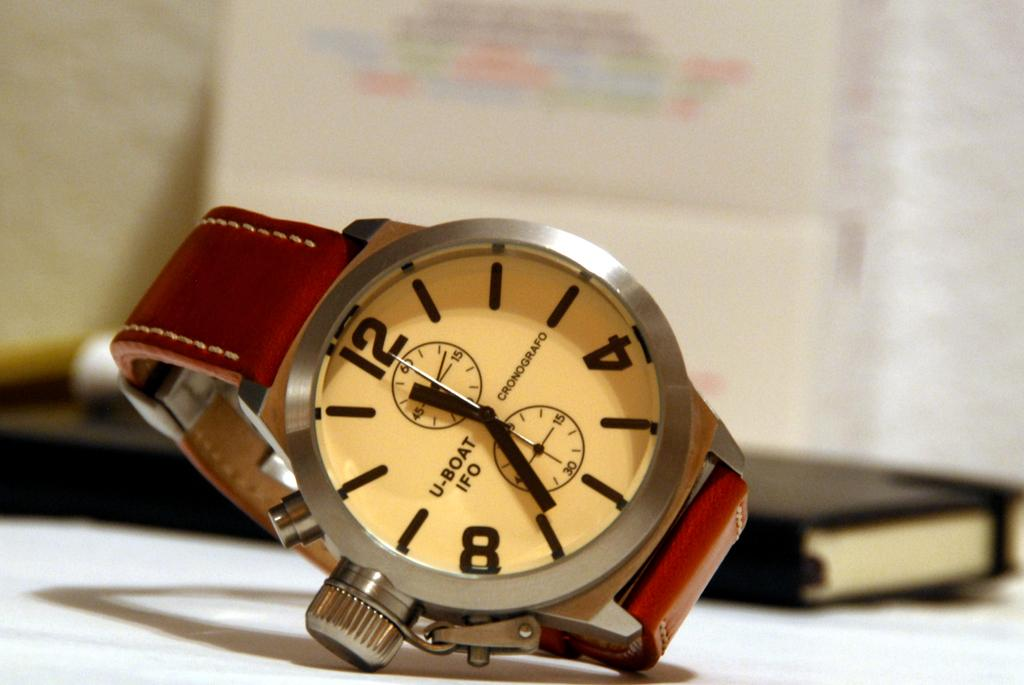<image>
Render a clear and concise summary of the photo. a watch face with one of the dials pointing at the 12 